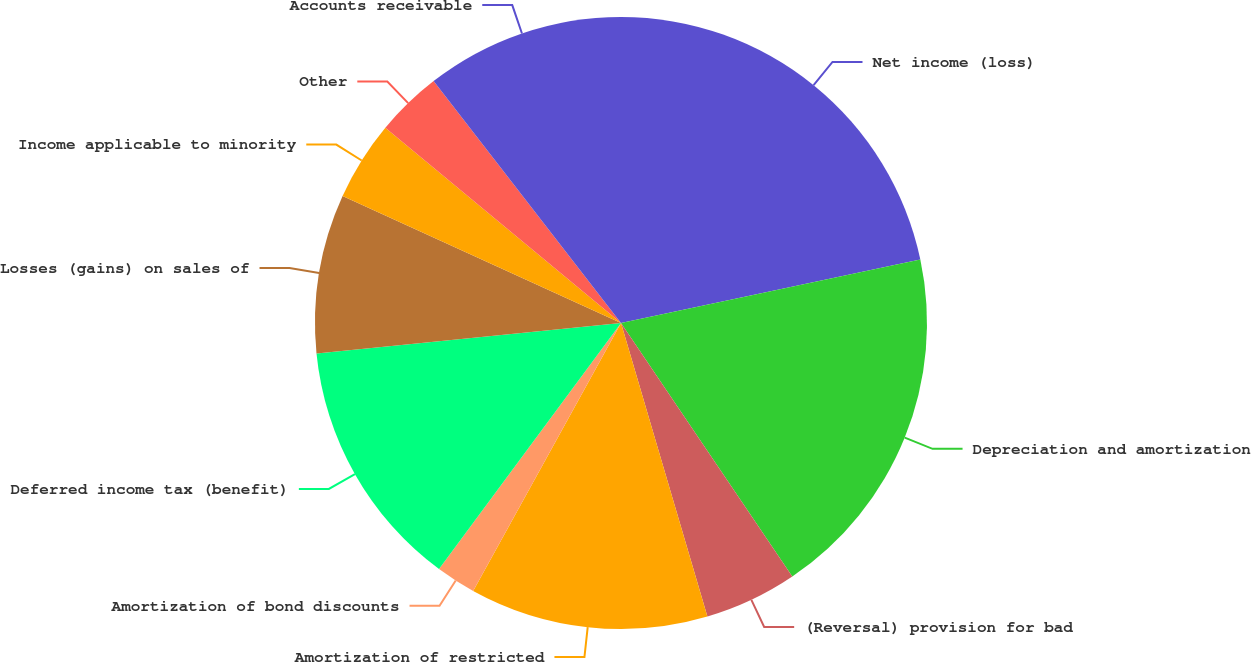Convert chart. <chart><loc_0><loc_0><loc_500><loc_500><pie_chart><fcel>Net income (loss)<fcel>Depreciation and amortization<fcel>(Reversal) provision for bad<fcel>Amortization of restricted<fcel>Amortization of bond discounts<fcel>Deferred income tax (benefit)<fcel>Losses (gains) on sales of<fcel>Income applicable to minority<fcel>Other<fcel>Accounts receivable<nl><fcel>21.67%<fcel>18.87%<fcel>4.9%<fcel>12.58%<fcel>2.11%<fcel>13.28%<fcel>8.39%<fcel>4.2%<fcel>3.5%<fcel>10.49%<nl></chart> 